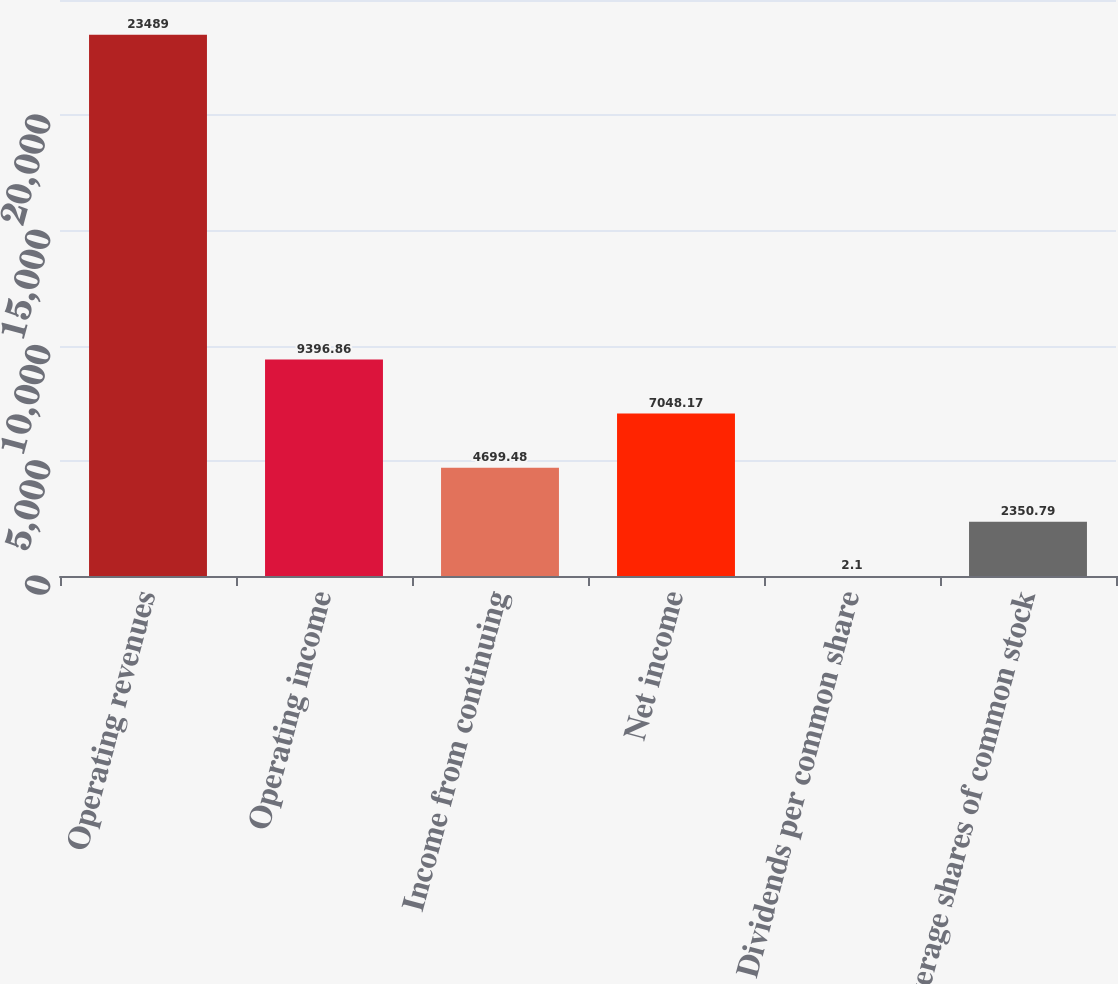<chart> <loc_0><loc_0><loc_500><loc_500><bar_chart><fcel>Operating revenues<fcel>Operating income<fcel>Income from continuing<fcel>Net income<fcel>Dividends per common share<fcel>Average shares of common stock<nl><fcel>23489<fcel>9396.86<fcel>4699.48<fcel>7048.17<fcel>2.1<fcel>2350.79<nl></chart> 